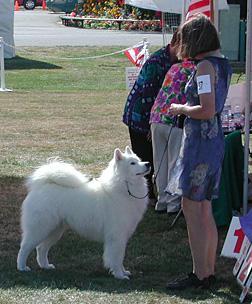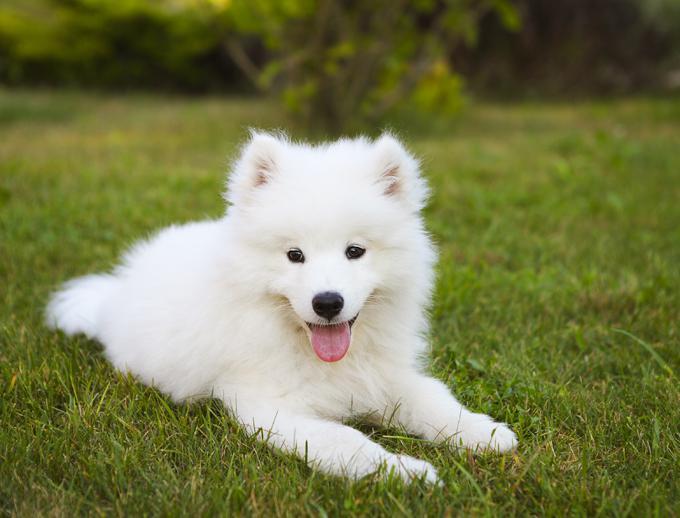The first image is the image on the left, the second image is the image on the right. Assess this claim about the two images: "An image with one dog shows a person standing outdoors next to the dog on a leash.". Correct or not? Answer yes or no. Yes. The first image is the image on the left, the second image is the image on the right. For the images shown, is this caption "One of the white dogs is lying on the green grass." true? Answer yes or no. Yes. 